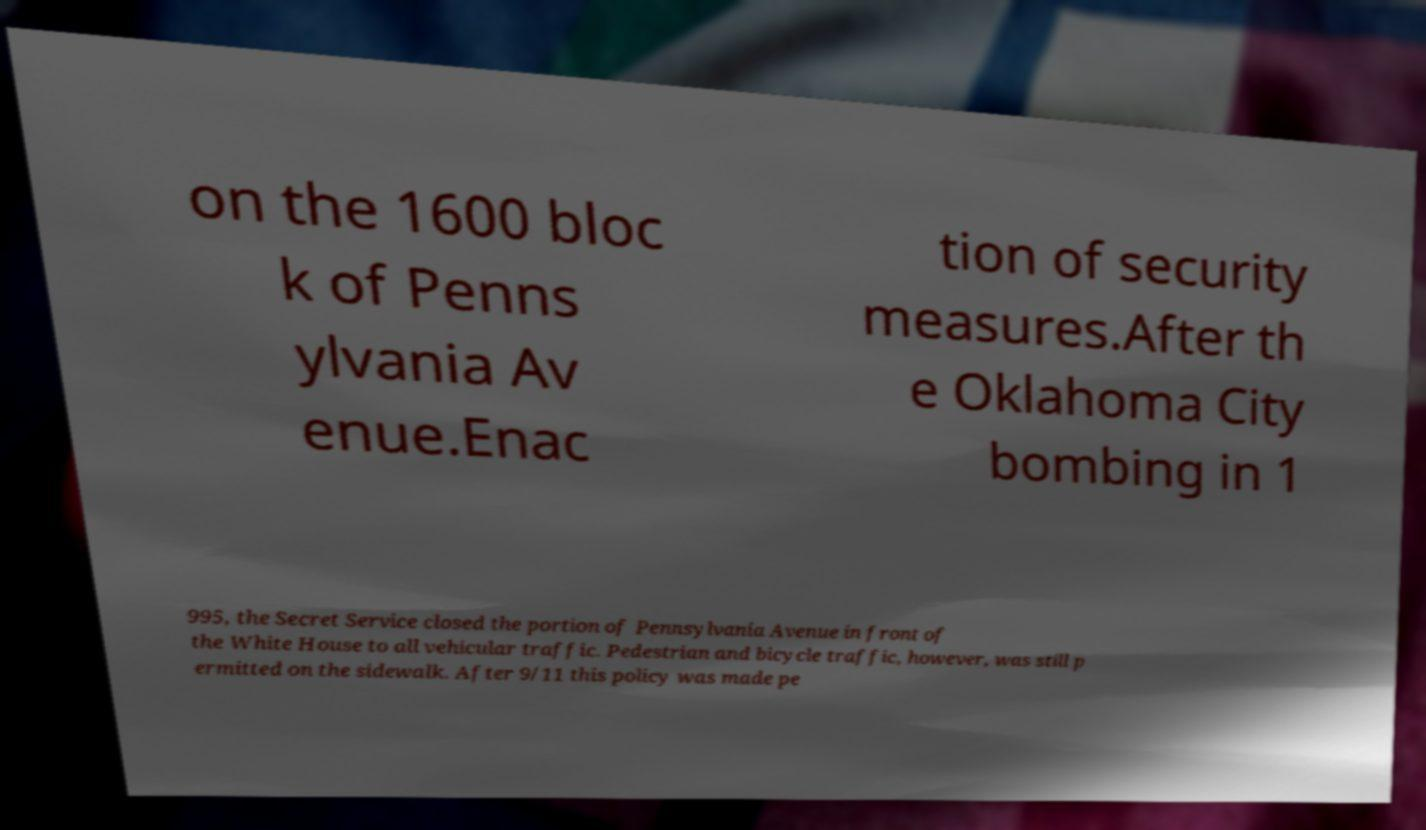Can you accurately transcribe the text from the provided image for me? on the 1600 bloc k of Penns ylvania Av enue.Enac tion of security measures.After th e Oklahoma City bombing in 1 995, the Secret Service closed the portion of Pennsylvania Avenue in front of the White House to all vehicular traffic. Pedestrian and bicycle traffic, however, was still p ermitted on the sidewalk. After 9/11 this policy was made pe 